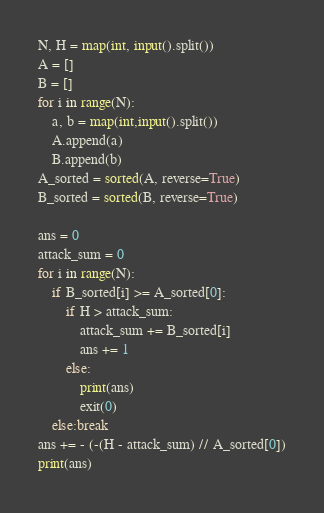Convert code to text. <code><loc_0><loc_0><loc_500><loc_500><_Python_>N, H = map(int, input().split())
A = []
B = []
for i in range(N):
    a, b = map(int,input().split())
    A.append(a)
    B.append(b)
A_sorted = sorted(A, reverse=True)
B_sorted = sorted(B, reverse=True)

ans = 0
attack_sum = 0
for i in range(N):
    if B_sorted[i] >= A_sorted[0]:
        if H > attack_sum:
            attack_sum += B_sorted[i]
            ans += 1
        else:
            print(ans)
            exit(0)
    else:break
ans += - (-(H - attack_sum) // A_sorted[0])
print(ans)

</code> 